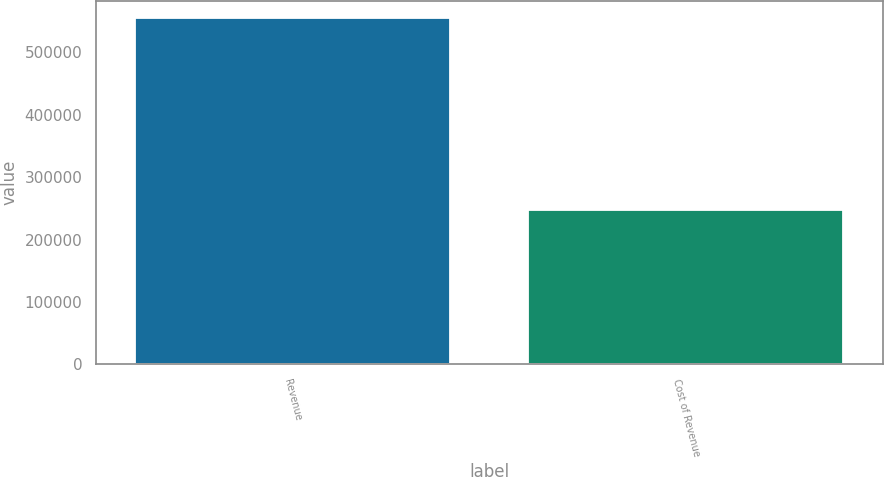<chart> <loc_0><loc_0><loc_500><loc_500><bar_chart><fcel>Revenue<fcel>Cost of Revenue<nl><fcel>555287<fcel>248215<nl></chart> 